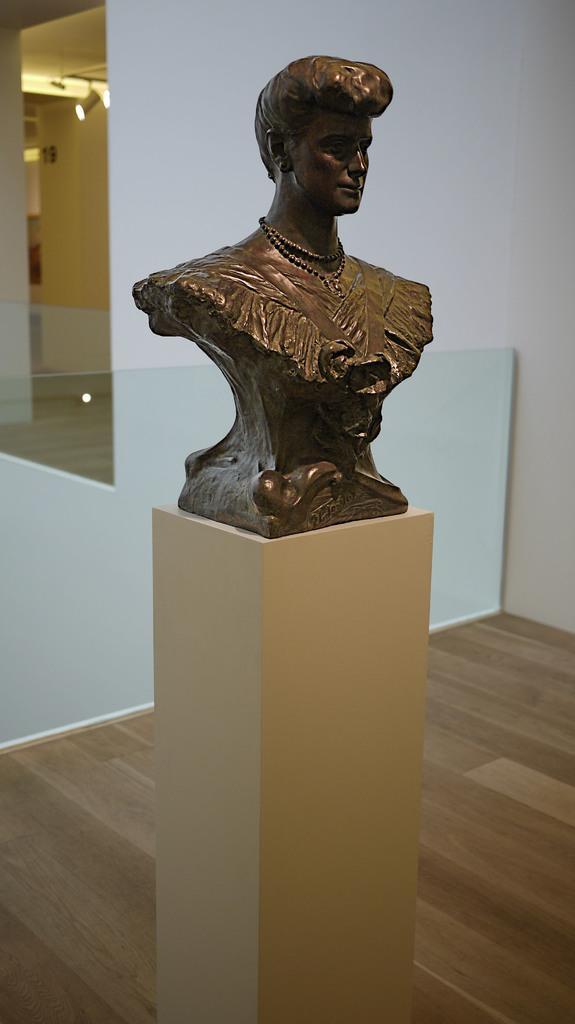Describe this image in one or two sentences. In this image in front there is a statue on the pillar. Behind the statue there is a glass fence. In the background of the image there is a wall. There are lights. At the bottom of the image there is a wooden floor. 